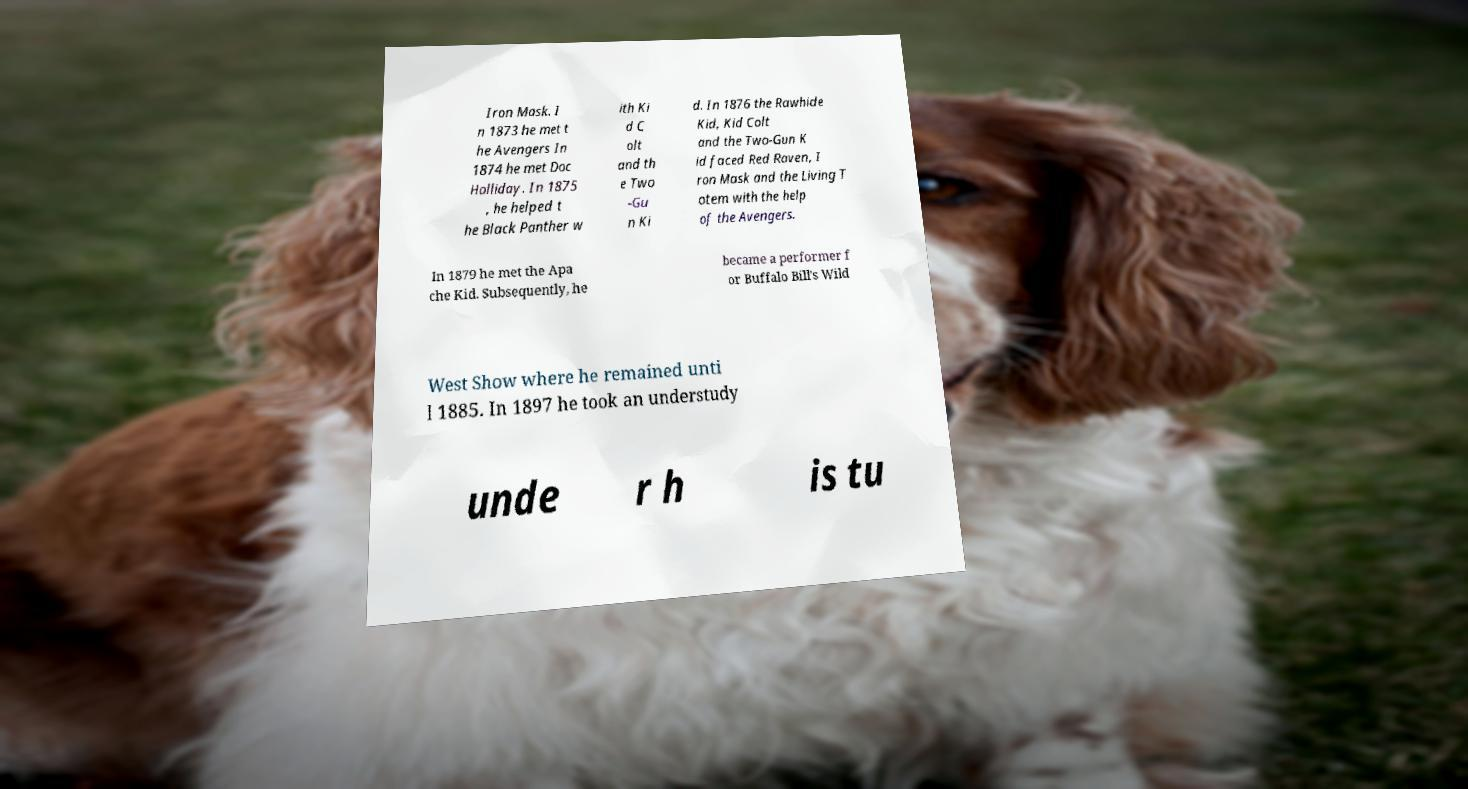Could you extract and type out the text from this image? Iron Mask. I n 1873 he met t he Avengers In 1874 he met Doc Holliday. In 1875 , he helped t he Black Panther w ith Ki d C olt and th e Two -Gu n Ki d. In 1876 the Rawhide Kid, Kid Colt and the Two-Gun K id faced Red Raven, I ron Mask and the Living T otem with the help of the Avengers. In 1879 he met the Apa che Kid. Subsequently, he became a performer f or Buffalo Bill's Wild West Show where he remained unti l 1885. In 1897 he took an understudy unde r h is tu 